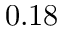Convert formula to latex. <formula><loc_0><loc_0><loc_500><loc_500>0 . 1 8</formula> 